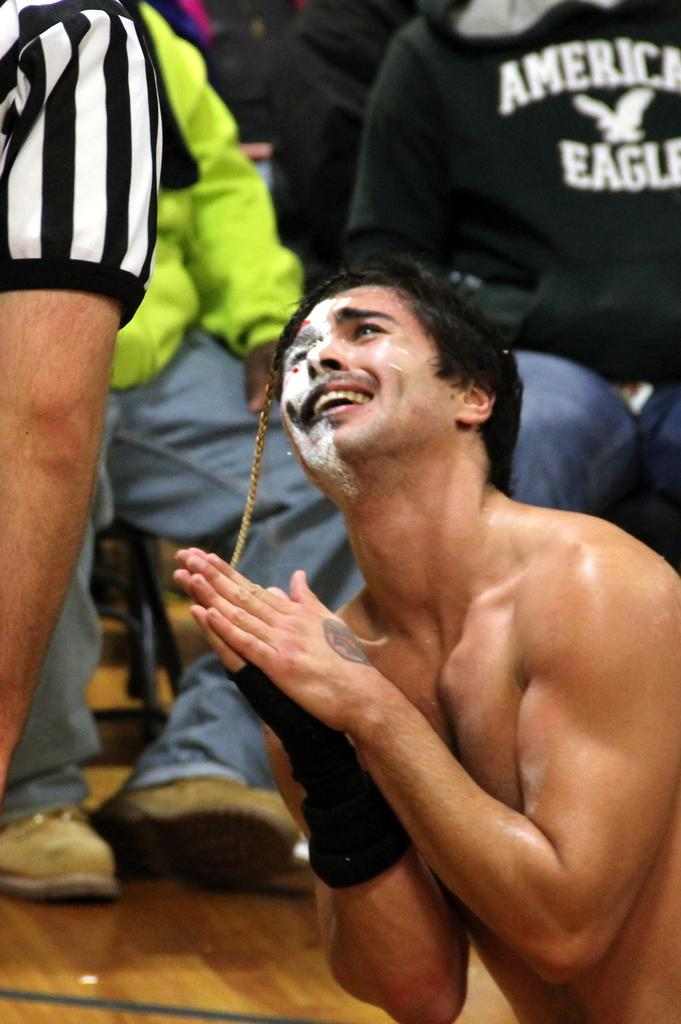<image>
Create a compact narrative representing the image presented. a man pleading near an American Eagle shirt 